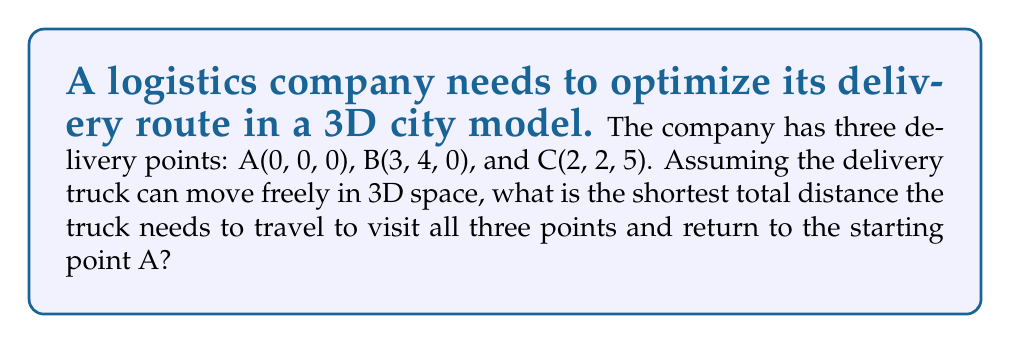Solve this math problem. To solve this problem, we need to follow these steps:

1. Calculate the distances between each pair of points using the 3D distance formula:
   $$d = \sqrt{(x_2-x_1)^2 + (y_2-y_1)^2 + (z_2-z_1)^2}$$

2. Find the shortest path that visits all points and returns to the starting point.

Step 1: Calculate distances

AB: $$d_{AB} = \sqrt{(3-0)^2 + (4-0)^2 + (0-0)^2} = \sqrt{9 + 16 + 0} = 5$$

AC: $$d_{AC} = \sqrt{(2-0)^2 + (2-0)^2 + (5-0)^2} = \sqrt{4 + 4 + 25} = \sqrt{33}$$

BC: $$d_{BC} = \sqrt{(2-3)^2 + (2-4)^2 + (5-0)^2} = \sqrt{1 + 4 + 25} = \sqrt{30}$$

Step 2: Find the shortest path

The possible paths are:
1. A → B → C → A
2. A → C → B → A

Path 1: $$d_{AB} + d_{BC} + d_{AC} = 5 + \sqrt{30} + \sqrt{33}$$
Path 2: $$d_{AC} + d_{BC} + d_{AB} = \sqrt{33} + \sqrt{30} + 5$$

Both paths have the same total distance, so either can be chosen as the optimal route.

The total distance traveled is:
$$5 + \sqrt{30} + \sqrt{33} \approx 16.5349$$

[asy]
import three;
size(200);
currentprojection=perspective(6,3,2);
draw(O--3X--3X+4Y--5Z--O,blue);
dot("A",O,N);
dot("B",(3,4,0),E);
dot("C",(2,2,5),W);
[/asy]
Answer: $5 + \sqrt{30} + \sqrt{33}$ 